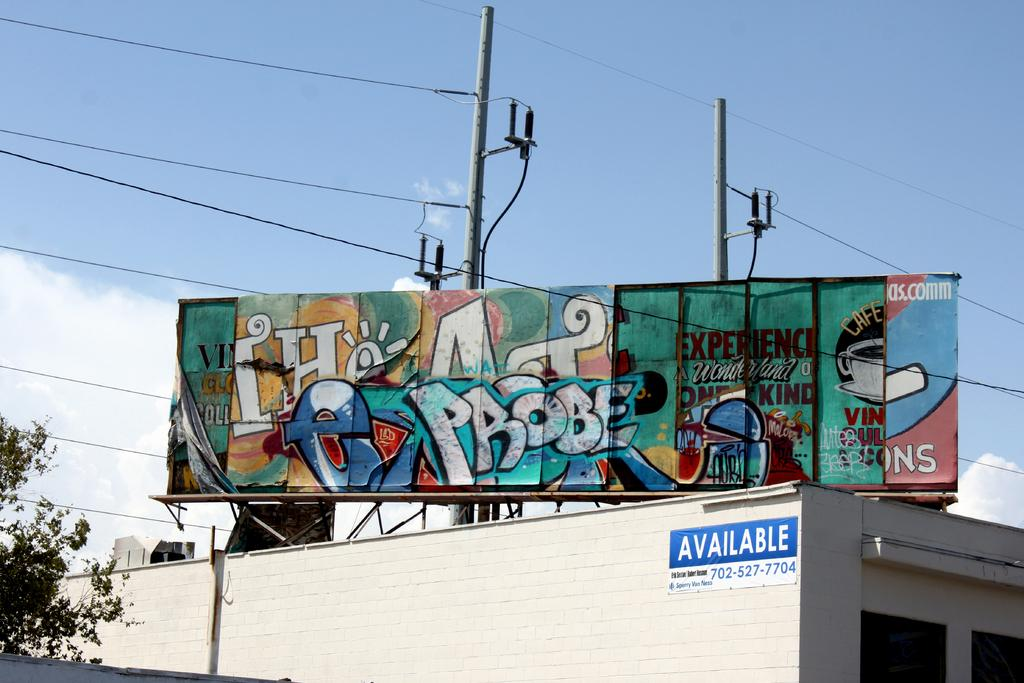<image>
Relay a brief, clear account of the picture shown. Space is available in a building below the graffiti covered billboard. 